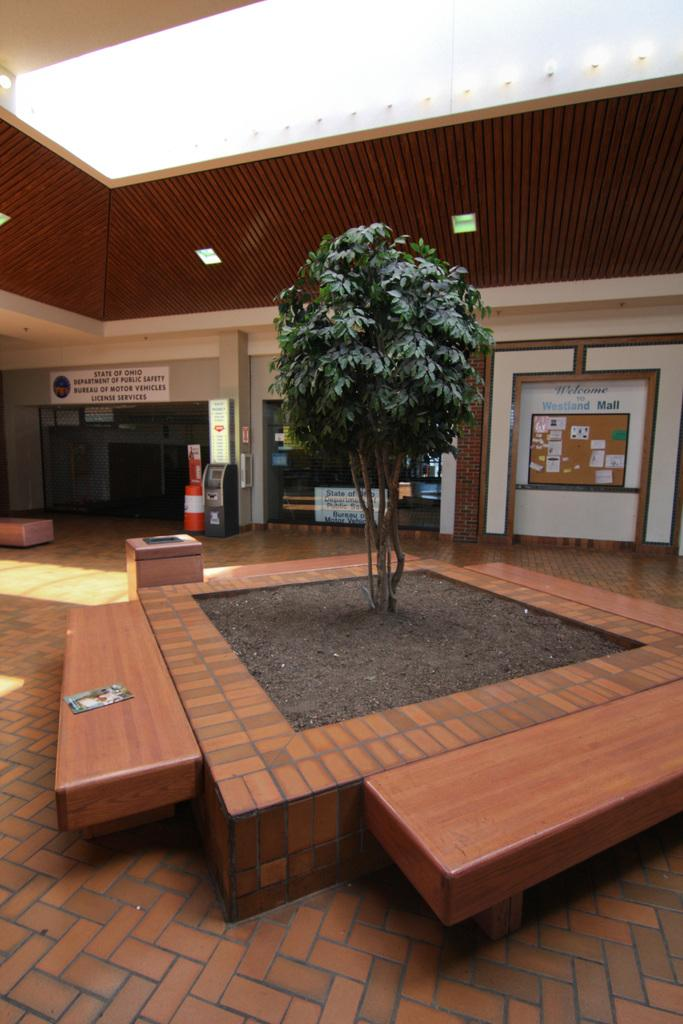What type of plant can be seen in the image? There is a plant in the image, but the specific type cannot be determined from the facts provided. What type of seating is available in the image? There are wooden benches in the image. What kind of machine is present in the image? There is a machine in the image, but the specific type cannot be determined from the facts provided. What type of structures are present in the image? There are boards and stores in the image. What part of the environment is visible in the background of the image? The ceiling is visible in the background of the image. Can you tell me how many veins are visible in the image? There are no veins present in the image. What type of army is depicted in the image? There is no army depicted in the image. 